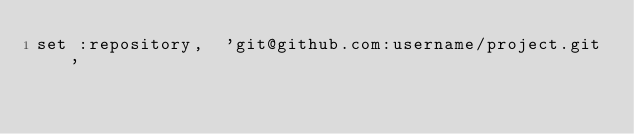Convert code to text. <code><loc_0><loc_0><loc_500><loc_500><_Ruby_>set :repository,  'git@github.com:username/project.git'
</code> 